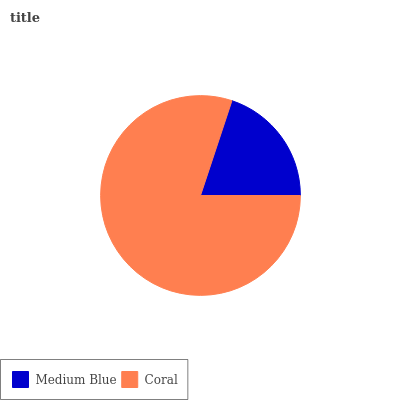Is Medium Blue the minimum?
Answer yes or no. Yes. Is Coral the maximum?
Answer yes or no. Yes. Is Coral the minimum?
Answer yes or no. No. Is Coral greater than Medium Blue?
Answer yes or no. Yes. Is Medium Blue less than Coral?
Answer yes or no. Yes. Is Medium Blue greater than Coral?
Answer yes or no. No. Is Coral less than Medium Blue?
Answer yes or no. No. Is Coral the high median?
Answer yes or no. Yes. Is Medium Blue the low median?
Answer yes or no. Yes. Is Medium Blue the high median?
Answer yes or no. No. Is Coral the low median?
Answer yes or no. No. 